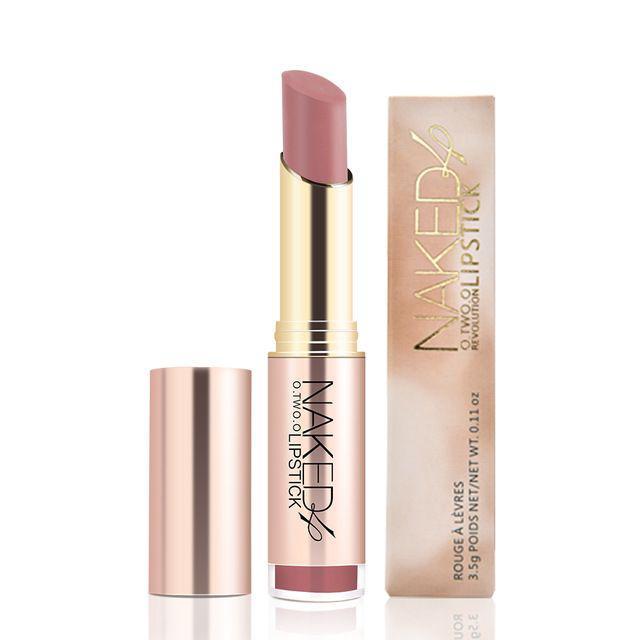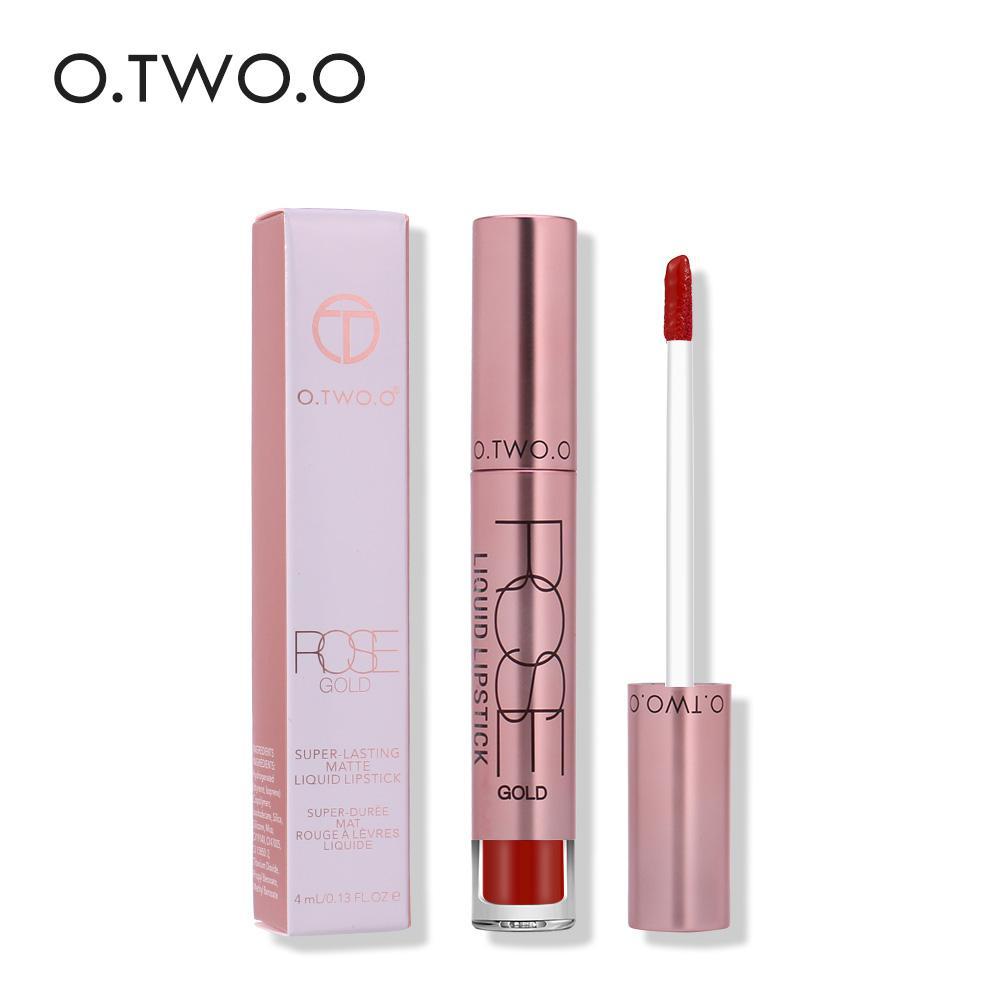The first image is the image on the left, the second image is the image on the right. Evaluate the accuracy of this statement regarding the images: "There are more upright tubes of lipstick in the image on the right.". Is it true? Answer yes or no. No. The first image is the image on the left, the second image is the image on the right. For the images displayed, is the sentence "An image shows only an unpackaged lipstick wand makeup, and does not show a standard tube lipstick or a box." factually correct? Answer yes or no. No. 